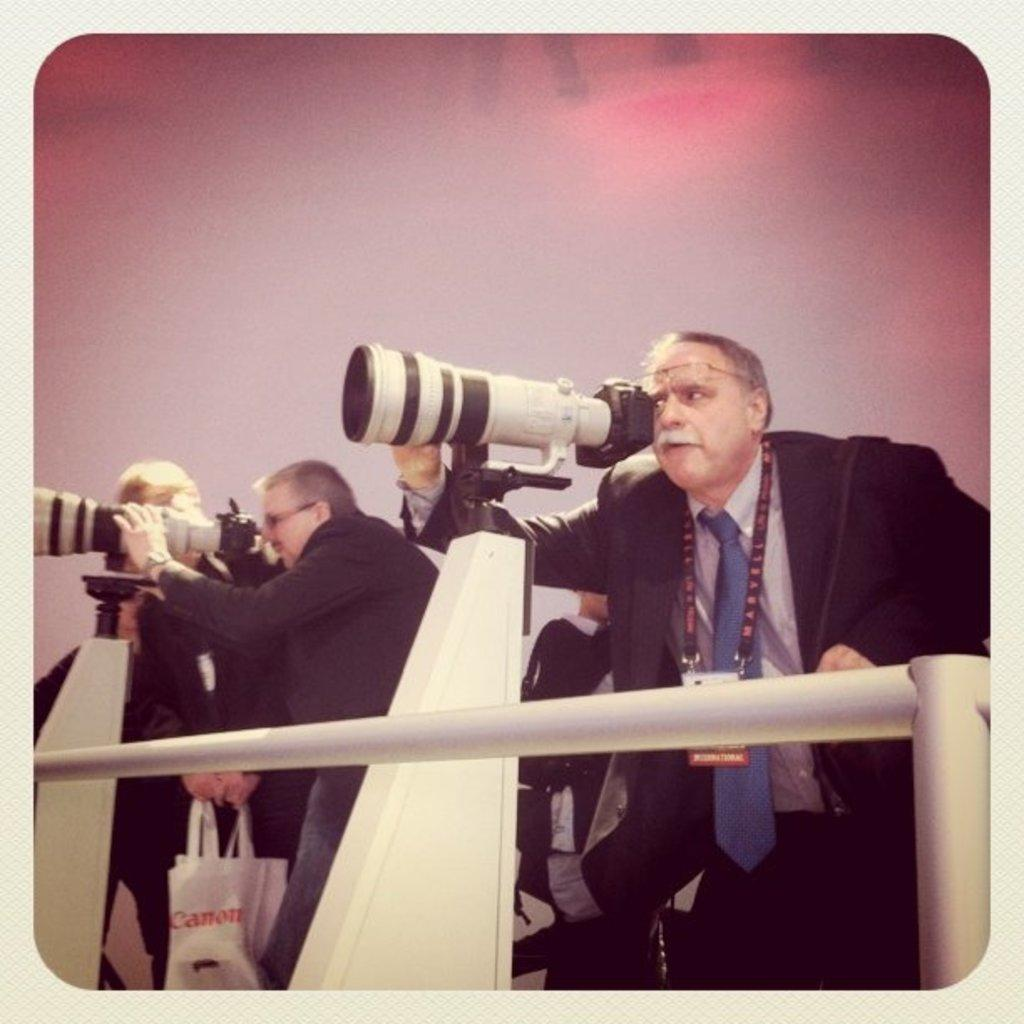What are the men in the image doing? Some of the men are peeping through a camera in the image. What is the camera equipped with? The camera has a lens. How is the lens positioned in the image? The lens is placed on a stand. Can you see any ants crawling on the camera lens in the image? There are no ants visible in the image, and the camera lens is not shown to be crawled upon by any insects. 